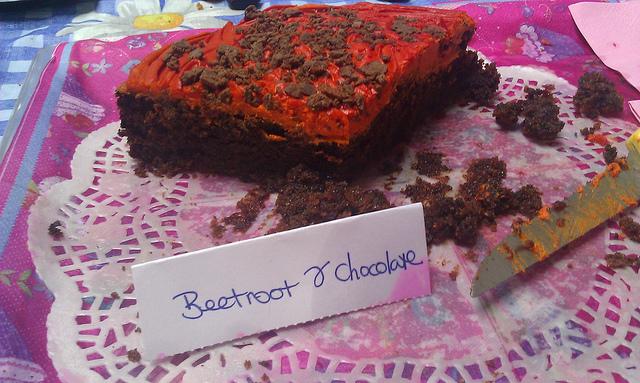What color is the frosting?
Keep it brief. Red. Would this cake be good for you to eat?
Give a very brief answer. Yes. Has this cake been cut yet?
Quick response, please. Yes. 